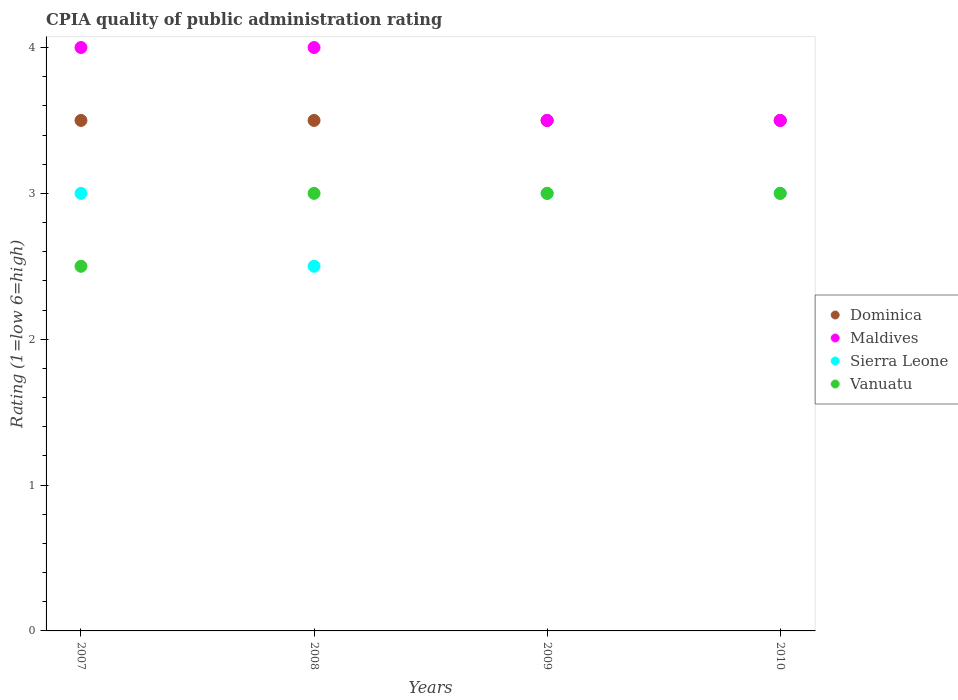Is the number of dotlines equal to the number of legend labels?
Provide a succinct answer. Yes. What is the CPIA rating in Sierra Leone in 2009?
Ensure brevity in your answer.  3. Across all years, what is the maximum CPIA rating in Vanuatu?
Provide a short and direct response. 3. Across all years, what is the minimum CPIA rating in Vanuatu?
Give a very brief answer. 2.5. In which year was the CPIA rating in Sierra Leone minimum?
Offer a very short reply. 2008. What is the total CPIA rating in Sierra Leone in the graph?
Ensure brevity in your answer.  11.5. What is the difference between the CPIA rating in Dominica in 2008 and that in 2009?
Your answer should be compact. 0. What is the difference between the CPIA rating in Sierra Leone in 2009 and the CPIA rating in Maldives in 2007?
Make the answer very short. -1. What is the average CPIA rating in Dominica per year?
Offer a terse response. 3.5. In the year 2010, what is the difference between the CPIA rating in Maldives and CPIA rating in Sierra Leone?
Give a very brief answer. 0.5. In how many years, is the CPIA rating in Sierra Leone greater than 2?
Give a very brief answer. 4. What is the difference between the highest and the second highest CPIA rating in Vanuatu?
Give a very brief answer. 0. Is the sum of the CPIA rating in Maldives in 2007 and 2009 greater than the maximum CPIA rating in Dominica across all years?
Keep it short and to the point. Yes. Is it the case that in every year, the sum of the CPIA rating in Sierra Leone and CPIA rating in Dominica  is greater than the sum of CPIA rating in Vanuatu and CPIA rating in Maldives?
Give a very brief answer. No. Is the CPIA rating in Vanuatu strictly greater than the CPIA rating in Maldives over the years?
Provide a short and direct response. No. Is the CPIA rating in Dominica strictly less than the CPIA rating in Maldives over the years?
Provide a succinct answer. No. How many dotlines are there?
Offer a terse response. 4. How many years are there in the graph?
Offer a terse response. 4. Does the graph contain any zero values?
Ensure brevity in your answer.  No. Where does the legend appear in the graph?
Provide a succinct answer. Center right. How many legend labels are there?
Keep it short and to the point. 4. How are the legend labels stacked?
Provide a succinct answer. Vertical. What is the title of the graph?
Offer a very short reply. CPIA quality of public administration rating. Does "Macedonia" appear as one of the legend labels in the graph?
Keep it short and to the point. No. What is the label or title of the Y-axis?
Give a very brief answer. Rating (1=low 6=high). What is the Rating (1=low 6=high) in Maldives in 2007?
Keep it short and to the point. 4. What is the Rating (1=low 6=high) in Sierra Leone in 2007?
Ensure brevity in your answer.  3. What is the Rating (1=low 6=high) in Vanuatu in 2007?
Provide a succinct answer. 2.5. What is the Rating (1=low 6=high) of Dominica in 2008?
Provide a short and direct response. 3.5. What is the Rating (1=low 6=high) in Vanuatu in 2008?
Give a very brief answer. 3. What is the Rating (1=low 6=high) in Maldives in 2009?
Your answer should be very brief. 3.5. What is the Rating (1=low 6=high) of Vanuatu in 2009?
Your answer should be compact. 3. What is the Rating (1=low 6=high) in Dominica in 2010?
Offer a terse response. 3.5. What is the Rating (1=low 6=high) in Maldives in 2010?
Your answer should be very brief. 3.5. What is the Rating (1=low 6=high) of Sierra Leone in 2010?
Ensure brevity in your answer.  3. What is the Rating (1=low 6=high) of Vanuatu in 2010?
Provide a succinct answer. 3. Across all years, what is the maximum Rating (1=low 6=high) in Dominica?
Provide a succinct answer. 3.5. Across all years, what is the maximum Rating (1=low 6=high) of Vanuatu?
Ensure brevity in your answer.  3. Across all years, what is the minimum Rating (1=low 6=high) in Maldives?
Your answer should be very brief. 3.5. Across all years, what is the minimum Rating (1=low 6=high) in Sierra Leone?
Your answer should be compact. 2.5. Across all years, what is the minimum Rating (1=low 6=high) of Vanuatu?
Offer a terse response. 2.5. What is the total Rating (1=low 6=high) of Sierra Leone in the graph?
Your answer should be very brief. 11.5. What is the total Rating (1=low 6=high) in Vanuatu in the graph?
Offer a very short reply. 11.5. What is the difference between the Rating (1=low 6=high) in Maldives in 2007 and that in 2008?
Offer a very short reply. 0. What is the difference between the Rating (1=low 6=high) in Dominica in 2007 and that in 2009?
Provide a short and direct response. 0. What is the difference between the Rating (1=low 6=high) in Sierra Leone in 2007 and that in 2009?
Provide a short and direct response. 0. What is the difference between the Rating (1=low 6=high) in Dominica in 2007 and that in 2010?
Provide a succinct answer. 0. What is the difference between the Rating (1=low 6=high) of Sierra Leone in 2007 and that in 2010?
Ensure brevity in your answer.  0. What is the difference between the Rating (1=low 6=high) of Vanuatu in 2007 and that in 2010?
Your answer should be compact. -0.5. What is the difference between the Rating (1=low 6=high) of Vanuatu in 2008 and that in 2009?
Your answer should be compact. 0. What is the difference between the Rating (1=low 6=high) of Maldives in 2008 and that in 2010?
Your response must be concise. 0.5. What is the difference between the Rating (1=low 6=high) in Vanuatu in 2008 and that in 2010?
Give a very brief answer. 0. What is the difference between the Rating (1=low 6=high) of Dominica in 2009 and that in 2010?
Provide a short and direct response. 0. What is the difference between the Rating (1=low 6=high) of Sierra Leone in 2009 and that in 2010?
Your response must be concise. 0. What is the difference between the Rating (1=low 6=high) in Dominica in 2007 and the Rating (1=low 6=high) in Vanuatu in 2008?
Offer a terse response. 0.5. What is the difference between the Rating (1=low 6=high) of Maldives in 2007 and the Rating (1=low 6=high) of Sierra Leone in 2008?
Your answer should be very brief. 1.5. What is the difference between the Rating (1=low 6=high) of Maldives in 2007 and the Rating (1=low 6=high) of Vanuatu in 2008?
Ensure brevity in your answer.  1. What is the difference between the Rating (1=low 6=high) of Dominica in 2007 and the Rating (1=low 6=high) of Sierra Leone in 2009?
Your response must be concise. 0.5. What is the difference between the Rating (1=low 6=high) in Maldives in 2007 and the Rating (1=low 6=high) in Sierra Leone in 2009?
Provide a short and direct response. 1. What is the difference between the Rating (1=low 6=high) in Dominica in 2007 and the Rating (1=low 6=high) in Maldives in 2010?
Keep it short and to the point. 0. What is the difference between the Rating (1=low 6=high) of Maldives in 2007 and the Rating (1=low 6=high) of Sierra Leone in 2010?
Offer a terse response. 1. What is the difference between the Rating (1=low 6=high) in Sierra Leone in 2007 and the Rating (1=low 6=high) in Vanuatu in 2010?
Your answer should be compact. 0. What is the difference between the Rating (1=low 6=high) in Dominica in 2008 and the Rating (1=low 6=high) in Vanuatu in 2009?
Ensure brevity in your answer.  0.5. What is the difference between the Rating (1=low 6=high) in Dominica in 2008 and the Rating (1=low 6=high) in Maldives in 2010?
Your answer should be compact. 0. What is the difference between the Rating (1=low 6=high) of Maldives in 2008 and the Rating (1=low 6=high) of Sierra Leone in 2010?
Ensure brevity in your answer.  1. What is the difference between the Rating (1=low 6=high) of Dominica in 2009 and the Rating (1=low 6=high) of Maldives in 2010?
Offer a terse response. 0. What is the difference between the Rating (1=low 6=high) of Dominica in 2009 and the Rating (1=low 6=high) of Sierra Leone in 2010?
Make the answer very short. 0.5. What is the difference between the Rating (1=low 6=high) in Dominica in 2009 and the Rating (1=low 6=high) in Vanuatu in 2010?
Ensure brevity in your answer.  0.5. What is the difference between the Rating (1=low 6=high) in Maldives in 2009 and the Rating (1=low 6=high) in Sierra Leone in 2010?
Provide a short and direct response. 0.5. What is the difference between the Rating (1=low 6=high) in Maldives in 2009 and the Rating (1=low 6=high) in Vanuatu in 2010?
Your response must be concise. 0.5. What is the difference between the Rating (1=low 6=high) in Sierra Leone in 2009 and the Rating (1=low 6=high) in Vanuatu in 2010?
Provide a succinct answer. 0. What is the average Rating (1=low 6=high) of Maldives per year?
Ensure brevity in your answer.  3.75. What is the average Rating (1=low 6=high) in Sierra Leone per year?
Make the answer very short. 2.88. What is the average Rating (1=low 6=high) of Vanuatu per year?
Provide a succinct answer. 2.88. In the year 2007, what is the difference between the Rating (1=low 6=high) of Dominica and Rating (1=low 6=high) of Sierra Leone?
Keep it short and to the point. 0.5. In the year 2007, what is the difference between the Rating (1=low 6=high) in Maldives and Rating (1=low 6=high) in Vanuatu?
Your answer should be compact. 1.5. In the year 2007, what is the difference between the Rating (1=low 6=high) in Sierra Leone and Rating (1=low 6=high) in Vanuatu?
Your response must be concise. 0.5. In the year 2008, what is the difference between the Rating (1=low 6=high) of Dominica and Rating (1=low 6=high) of Vanuatu?
Your answer should be very brief. 0.5. In the year 2008, what is the difference between the Rating (1=low 6=high) of Sierra Leone and Rating (1=low 6=high) of Vanuatu?
Offer a terse response. -0.5. In the year 2009, what is the difference between the Rating (1=low 6=high) in Dominica and Rating (1=low 6=high) in Sierra Leone?
Provide a succinct answer. 0.5. In the year 2009, what is the difference between the Rating (1=low 6=high) of Maldives and Rating (1=low 6=high) of Sierra Leone?
Make the answer very short. 0.5. In the year 2009, what is the difference between the Rating (1=low 6=high) in Maldives and Rating (1=low 6=high) in Vanuatu?
Provide a short and direct response. 0.5. In the year 2009, what is the difference between the Rating (1=low 6=high) of Sierra Leone and Rating (1=low 6=high) of Vanuatu?
Your answer should be very brief. 0. In the year 2010, what is the difference between the Rating (1=low 6=high) in Dominica and Rating (1=low 6=high) in Maldives?
Offer a terse response. 0. In the year 2010, what is the difference between the Rating (1=low 6=high) in Dominica and Rating (1=low 6=high) in Sierra Leone?
Keep it short and to the point. 0.5. In the year 2010, what is the difference between the Rating (1=low 6=high) of Dominica and Rating (1=low 6=high) of Vanuatu?
Your answer should be very brief. 0.5. In the year 2010, what is the difference between the Rating (1=low 6=high) in Maldives and Rating (1=low 6=high) in Vanuatu?
Your response must be concise. 0.5. What is the ratio of the Rating (1=low 6=high) in Maldives in 2007 to that in 2008?
Your answer should be compact. 1. What is the ratio of the Rating (1=low 6=high) of Vanuatu in 2007 to that in 2008?
Keep it short and to the point. 0.83. What is the ratio of the Rating (1=low 6=high) in Dominica in 2007 to that in 2009?
Your answer should be very brief. 1. What is the ratio of the Rating (1=low 6=high) of Sierra Leone in 2007 to that in 2009?
Your answer should be very brief. 1. What is the ratio of the Rating (1=low 6=high) in Vanuatu in 2007 to that in 2009?
Ensure brevity in your answer.  0.83. What is the ratio of the Rating (1=low 6=high) in Maldives in 2007 to that in 2010?
Your answer should be very brief. 1.14. What is the ratio of the Rating (1=low 6=high) of Dominica in 2008 to that in 2009?
Offer a very short reply. 1. What is the ratio of the Rating (1=low 6=high) of Vanuatu in 2008 to that in 2009?
Your response must be concise. 1. What is the ratio of the Rating (1=low 6=high) in Dominica in 2009 to that in 2010?
Your answer should be compact. 1. What is the ratio of the Rating (1=low 6=high) in Maldives in 2009 to that in 2010?
Offer a terse response. 1. What is the ratio of the Rating (1=low 6=high) in Vanuatu in 2009 to that in 2010?
Ensure brevity in your answer.  1. What is the difference between the highest and the second highest Rating (1=low 6=high) in Sierra Leone?
Your response must be concise. 0. What is the difference between the highest and the second highest Rating (1=low 6=high) of Vanuatu?
Your response must be concise. 0. What is the difference between the highest and the lowest Rating (1=low 6=high) of Dominica?
Provide a short and direct response. 0. What is the difference between the highest and the lowest Rating (1=low 6=high) in Sierra Leone?
Offer a terse response. 0.5. 